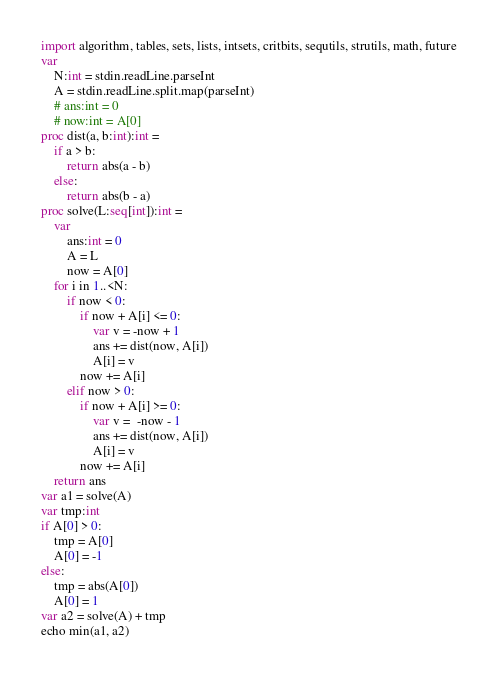<code> <loc_0><loc_0><loc_500><loc_500><_Nim_>import algorithm, tables, sets, lists, intsets, critbits, sequtils, strutils, math, future
var 
    N:int = stdin.readLine.parseInt
    A = stdin.readLine.split.map(parseInt)
    # ans:int = 0
    # now:int = A[0]
proc dist(a, b:int):int = 
    if a > b:
        return abs(a - b)
    else:
        return abs(b - a)
proc solve(L:seq[int]):int =
    var 
        ans:int = 0
        A = L
        now = A[0]
    for i in 1..<N:
        if now < 0:
            if now + A[i] <= 0:
                var v = -now + 1
                ans += dist(now, A[i])
                A[i] = v
            now += A[i]
        elif now > 0:
            if now + A[i] >= 0:
                var v =  -now - 1
                ans += dist(now, A[i])
                A[i] = v
            now += A[i]
    return ans
var a1 = solve(A)
var tmp:int
if A[0] > 0:
    tmp = A[0]
    A[0] = -1
else:
    tmp = abs(A[0])
    A[0] = 1
var a2 = solve(A) + tmp
echo min(a1, a2)</code> 